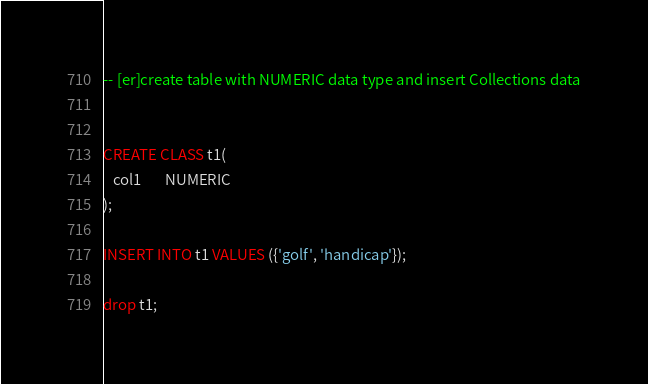<code> <loc_0><loc_0><loc_500><loc_500><_SQL_>-- [er]create table with NUMERIC data type and insert Collections data


CREATE CLASS t1(
   col1       NUMERIC
);

INSERT INTO t1 VALUES ({'golf', 'handicap'});

drop t1;</code> 